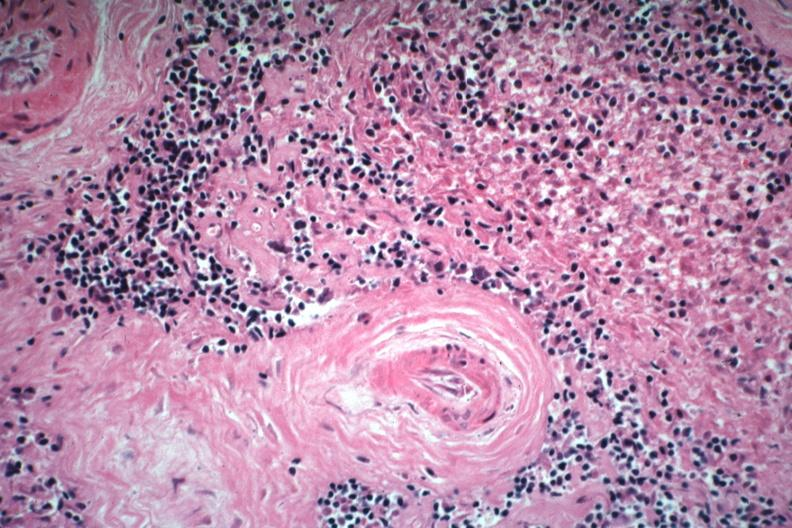what is present?
Answer the question using a single word or phrase. Hematologic 